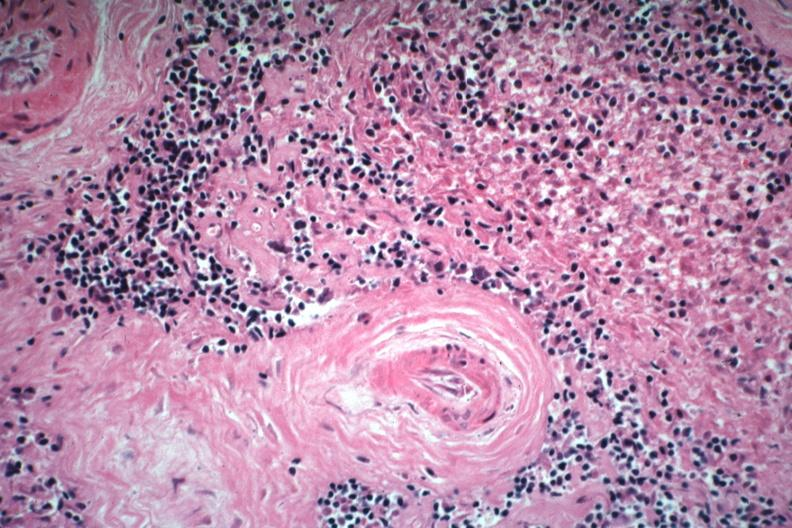what is present?
Answer the question using a single word or phrase. Hematologic 